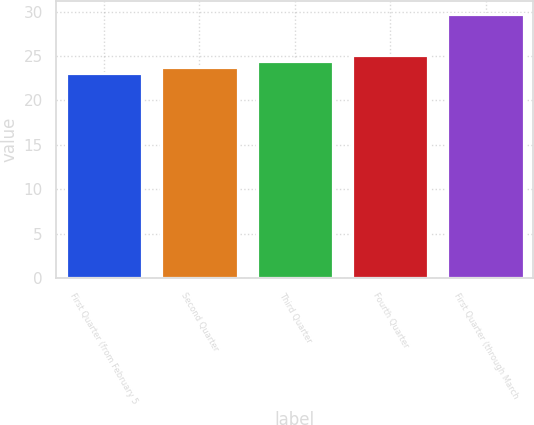<chart> <loc_0><loc_0><loc_500><loc_500><bar_chart><fcel>First Quarter (from February 5<fcel>Second Quarter<fcel>Third Quarter<fcel>Fourth Quarter<fcel>First Quarter (through March<nl><fcel>23.09<fcel>23.75<fcel>24.41<fcel>25.07<fcel>29.7<nl></chart> 